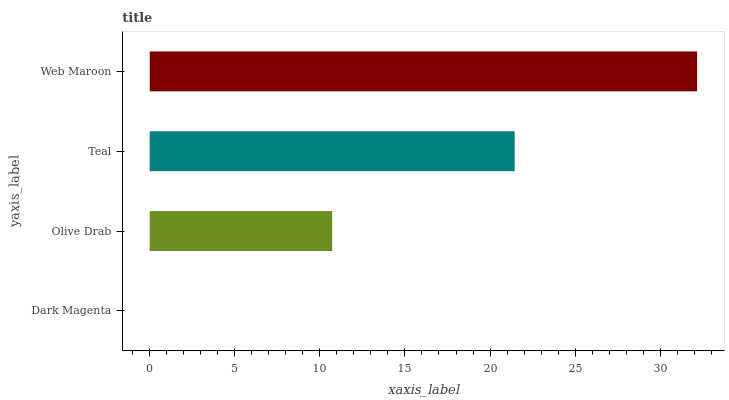Is Dark Magenta the minimum?
Answer yes or no. Yes. Is Web Maroon the maximum?
Answer yes or no. Yes. Is Olive Drab the minimum?
Answer yes or no. No. Is Olive Drab the maximum?
Answer yes or no. No. Is Olive Drab greater than Dark Magenta?
Answer yes or no. Yes. Is Dark Magenta less than Olive Drab?
Answer yes or no. Yes. Is Dark Magenta greater than Olive Drab?
Answer yes or no. No. Is Olive Drab less than Dark Magenta?
Answer yes or no. No. Is Teal the high median?
Answer yes or no. Yes. Is Olive Drab the low median?
Answer yes or no. Yes. Is Web Maroon the high median?
Answer yes or no. No. Is Teal the low median?
Answer yes or no. No. 